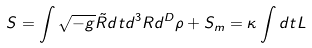Convert formula to latex. <formula><loc_0><loc_0><loc_500><loc_500>S = \int \sqrt { - g } \tilde { R } d t d ^ { 3 } R d ^ { D } \rho + S _ { m } = \kappa \int d t L</formula> 